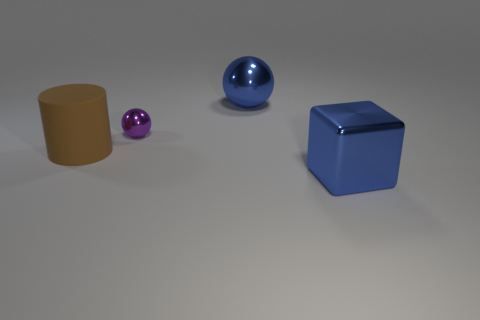There is a blue shiny object that is behind the purple metal thing; what number of blue cubes are in front of it?
Provide a succinct answer. 1. What number of big things are in front of the big metal sphere and behind the block?
Give a very brief answer. 1. What number of things are tiny green rubber balls or objects in front of the large blue metallic sphere?
Provide a short and direct response. 3. There is a purple object that is the same material as the large blue cube; what is its size?
Provide a succinct answer. Small. The large blue metallic object that is on the left side of the blue metal object in front of the purple metal object is what shape?
Keep it short and to the point. Sphere. What number of purple things are large things or small matte things?
Provide a short and direct response. 0. Are there any brown matte objects right of the large blue metal object in front of the purple ball behind the brown object?
Make the answer very short. No. What is the shape of the big object that is the same color as the big shiny cube?
Give a very brief answer. Sphere. Are there any other things that are the same material as the brown thing?
Provide a succinct answer. No. What number of big objects are either blocks or purple metal spheres?
Provide a succinct answer. 1. 